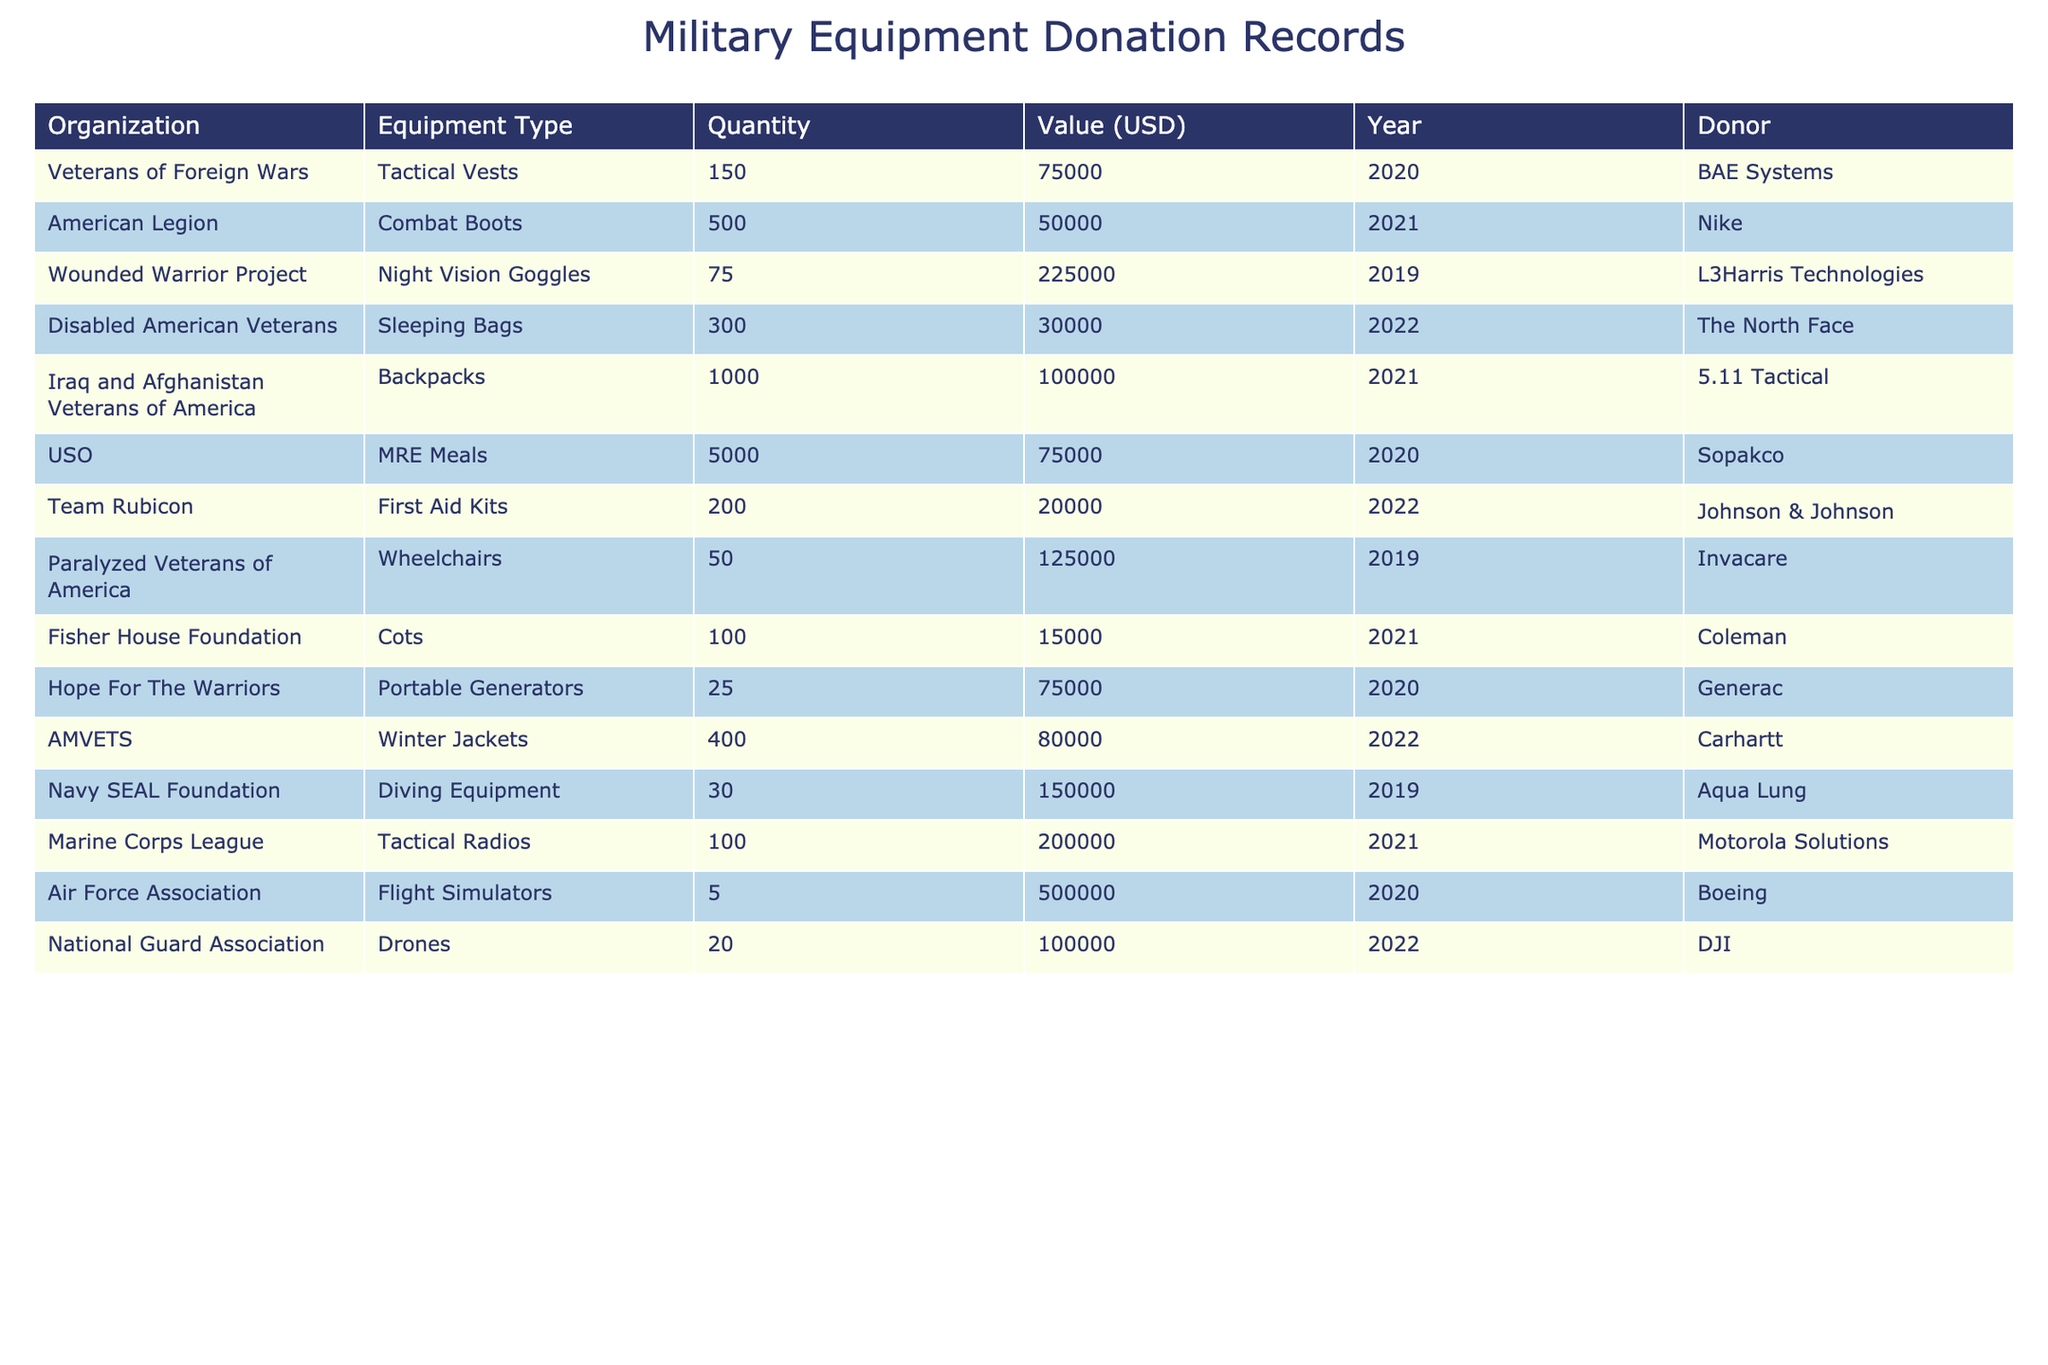What is the total quantity of tactical vests donated? The table shows 150 tactical vests donated to the Veterans of Foreign Wars. There are no other entries for tactical vests, so the total quantity is 150.
Answer: 150 Which organization received a donation of back packs? The table indicates that the Iraq and Afghanistan Veterans of America received a donation of 1,000 backpacks.
Answer: Iraq and Afghanistan Veterans of America What was the total value of the donations made in 2021? The values of the donations made in 2021 are 50,000 (American Legion) + 100,000 (Iraq and Afghanistan Veterans of America) + 15,000 (Fisher House Foundation) + 200,000 (Marine Corps League) + 75,000 (USO) + 80,000 (AMVETS) = 520,000.
Answer: 520000 How many different types of equipment were donated in the year 2020? In the year 2020, the table shows that tactical vests, MRE Meals, and portable generators were donated. This totals to 3 different types of equipment.
Answer: 3 Which donor provided the most valuable equipment? The Air Force Association received flight simulators worth 500,000 USD, which is the highest value in the table.
Answer: Air Force Association Is it true that all the equipment donated in 2019 was at least worth 100,000 USD? In 2019, the Wounded Warrior Project received night vision goggles worth 225,000 USD, and Paralyzed Veterans of America received wheelchairs worth 125,000 USD. Therefore, it is true that both donations in that year were worth at least 100,000 USD.
Answer: True What is the average value of the equipment donated by the USO? The total value donated by USO is 75,000 USD, with entries for just one type of equipment (MRE meals) in their row. Therefore, the average value is simply 75,000 USD divided by 1, which equals 75,000 USD.
Answer: 75000 If we only consider the equipment donated in 2022, what is the total quantity donated? The table shows Team Rubicon (200), Disabled American Veterans (300), AMVETS (400), and National Guard Association (20) for a total of 200 + 300 + 400 + 20 = 920.
Answer: 920 Which equipment type had the highest quantity donated overall? Backpacks, donated to the Iraq and Afghanistan Veterans of America, had the highest quantity at 1,000 units.
Answer: Backpacks Was any equipment valued at less than 20,000 USD? The table indicates there are no donations valued under 20,000 USD; the lowest value recorded is 15,000 USD for cots by Fisher House Foundation. So, the statement is false.
Answer: False 